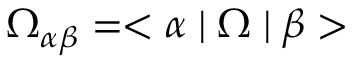Convert formula to latex. <formula><loc_0><loc_0><loc_500><loc_500>\Omega _ { \alpha \beta } = < \alpha | \Omega | \beta ></formula> 